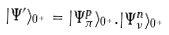Convert formula to latex. <formula><loc_0><loc_0><loc_500><loc_500>| \Psi ^ { \prime } \rangle _ { 0 ^ { + } } = | \Psi _ { \pi } ^ { p } \rangle _ { 0 ^ { + } } . | \Psi _ { \nu } ^ { n } \rangle _ { 0 ^ { + } }</formula> 